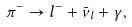<formula> <loc_0><loc_0><loc_500><loc_500>\pi ^ { - } \rightarrow l ^ { - } + \bar { \nu } _ { l } + \gamma ,</formula> 